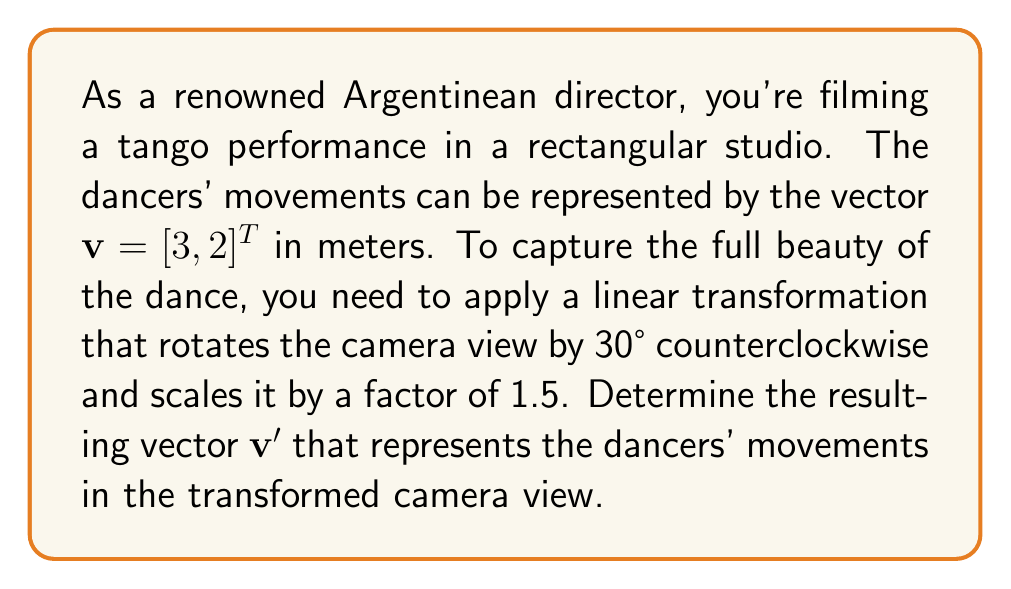Could you help me with this problem? To solve this problem, we'll follow these steps:

1) First, let's recall the rotation matrix for a counterclockwise rotation by θ:

   $$R_{\theta} = \begin{bmatrix} \cos\theta & -\sin\theta \\ \sin\theta & \cos\theta \end{bmatrix}$$

2) For a 30° rotation, θ = 30° = π/6 radians. Let's calculate the rotation matrix:

   $$R_{30°} = \begin{bmatrix} \cos(π/6) & -\sin(π/6) \\ \sin(π/6) & \cos(π/6) \end{bmatrix} = \begin{bmatrix} \frac{\sqrt{3}}{2} & -\frac{1}{2} \\ \frac{1}{2} & \frac{\sqrt{3}}{2} \end{bmatrix}$$

3) To scale by a factor of 1.5, we multiply the rotation matrix by 1.5:

   $$1.5 \cdot R_{30°} = \begin{bmatrix} 1.5\cdot\frac{\sqrt{3}}{2} & 1.5\cdot(-\frac{1}{2}) \\ 1.5\cdot\frac{1}{2} & 1.5\cdot\frac{\sqrt{3}}{2} \end{bmatrix} = \begin{bmatrix} \frac{3\sqrt{3}}{4} & -\frac{3}{4} \\ \frac{3}{4} & \frac{3\sqrt{3}}{4} \end{bmatrix}$$

4) Now, we apply this transformation to the original vector $\mathbf{v} = [3, 2]^T$:

   $$\mathbf{v}' = \begin{bmatrix} \frac{3\sqrt{3}}{4} & -\frac{3}{4} \\ \frac{3}{4} & \frac{3\sqrt{3}}{4} \end{bmatrix} \begin{bmatrix} 3 \\ 2 \end{bmatrix}$$

5) Multiplying the matrices:

   $$\mathbf{v}' = \begin{bmatrix} \frac{3\sqrt{3}}{4}(3) + (-\frac{3}{4})(2) \\ \frac{3}{4}(3) + \frac{3\sqrt{3}}{4}(2) \end{bmatrix} = \begin{bmatrix} \frac{9\sqrt{3}}{4} - \frac{3}{2} \\ \frac{9}{4} + \frac{3\sqrt{3}}{2} \end{bmatrix}$$

6) Simplifying:

   $$\mathbf{v}' = \begin{bmatrix} \frac{9\sqrt{3}-6}{4} \\ \frac{9+6\sqrt{3}}{4} \end{bmatrix} = \begin{bmatrix} \frac{9\sqrt{3}-6}{4} \\ \frac{9+6\sqrt{3}}{4} \end{bmatrix}$$
Answer: $\mathbf{v}' = [\frac{9\sqrt{3}-6}{4}, \frac{9+6\sqrt{3}}{4}]^T$ 